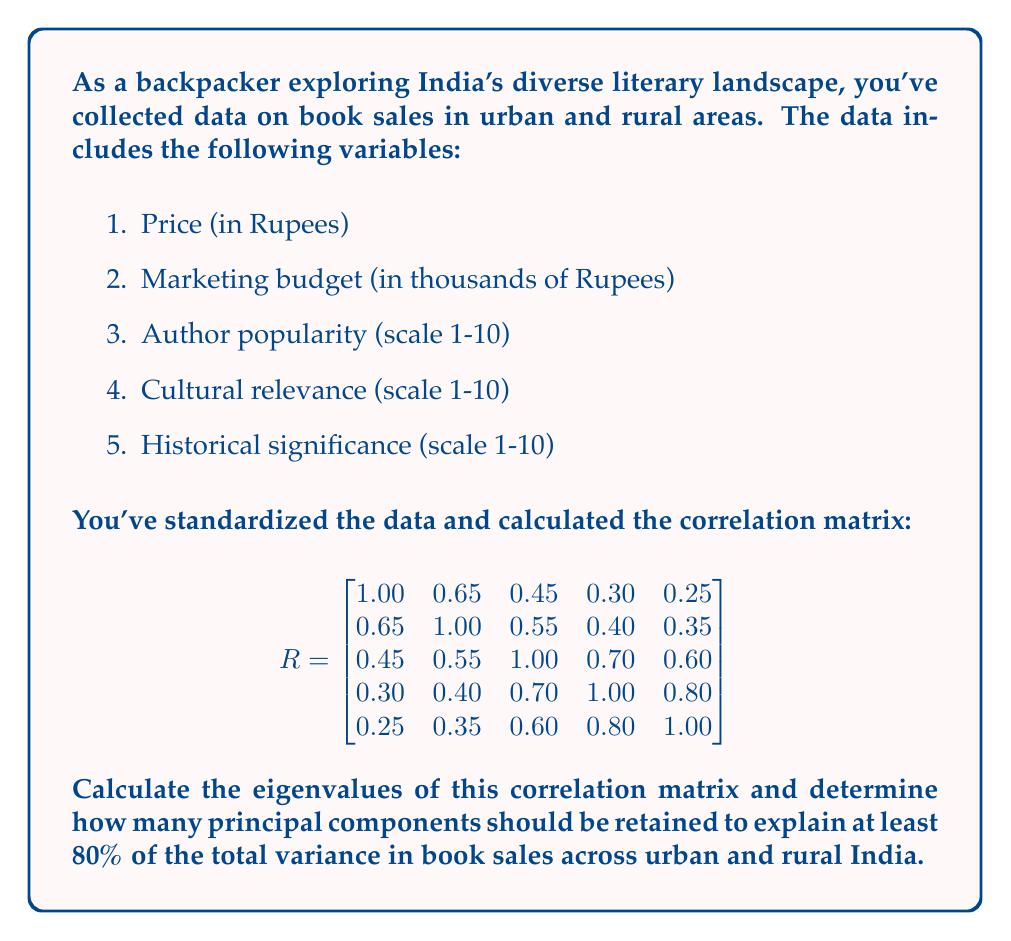Give your solution to this math problem. To solve this problem, we'll follow these steps:

1) Calculate the eigenvalues of the correlation matrix.
2) Calculate the proportion of variance explained by each eigenvalue.
3) Determine how many principal components to retain.

Step 1: Calculate the eigenvalues

We need to solve the characteristic equation $|R - \lambda I| = 0$. This is a 5th-degree polynomial, which is complex to solve by hand. Using a mathematical software or calculator, we get the following eigenvalues:

$\lambda_1 \approx 3.2954$
$\lambda_2 \approx 0.8691$
$\lambda_3 \approx 0.4555$
$\lambda_4 \approx 0.2385$
$\lambda_5 \approx 0.1415$

Step 2: Calculate the proportion of variance

The total variance is the sum of all eigenvalues, which equals the number of variables (5 in this case). The proportion of variance explained by each eigenvalue is:

$\text{Proportion}_i = \frac{\lambda_i}{\sum \lambda_i} = \frac{\lambda_i}{5}$

$\text{Proportion}_1 = 3.2954 / 5 = 0.6591 \text{ or } 65.91\%$
$\text{Proportion}_2 = 0.8691 / 5 = 0.1738 \text{ or } 17.38\%$
$\text{Proportion}_3 = 0.4555 / 5 = 0.0911 \text{ or } 9.11\%$
$\text{Proportion}_4 = 0.2385 / 5 = 0.0477 \text{ or } 4.77\%$
$\text{Proportion}_5 = 0.1415 / 5 = 0.0283 \text{ or } 2.83\%$

Step 3: Determine the number of principal components

We need to find how many components explain at least 80% of the variance. We'll sum the proportions until we reach or exceed 80%:

$\text{Cumulative Proportion}_1 = 65.91\%$
$\text{Cumulative Proportion}_2 = 65.91\% + 17.38\% = 83.29\%$

The first two principal components explain 83.29% of the total variance, which exceeds our 80% threshold.
Answer: 2 principal components 